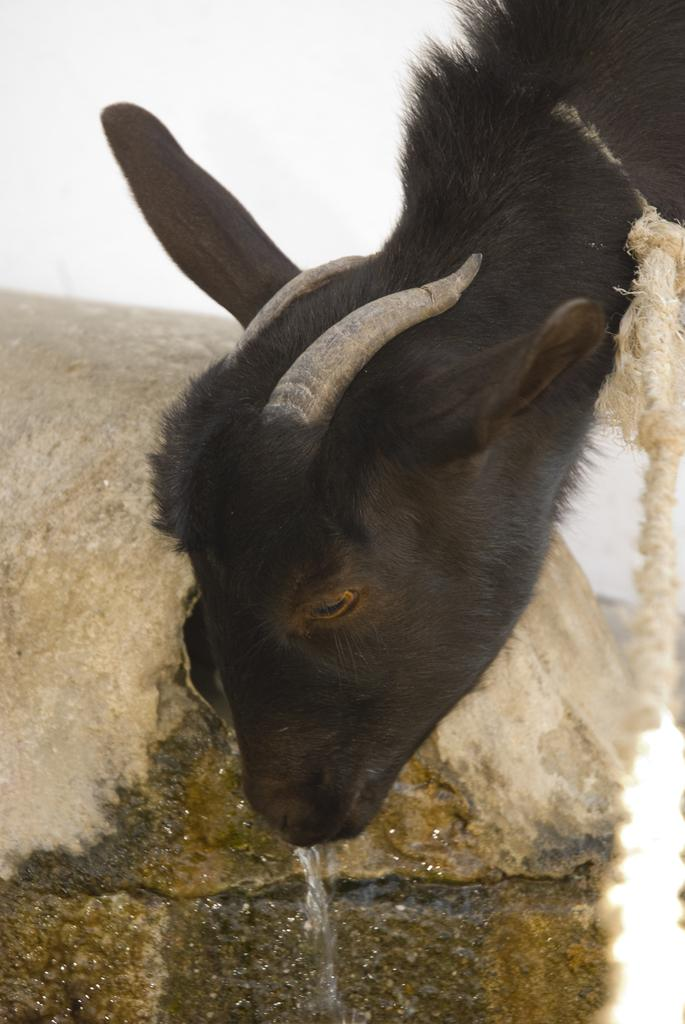What type of animal is in the image? There is an animal in the image, but the specific type cannot be determined from the provided facts. What is located at the bottom of the image? There is water at the bottom of the image. What can be seen in the background of the image? There is a rock and the sky visible in the background of the image. What hobbies does the animal have in the image? There is no information about the animal's hobbies in the image. 